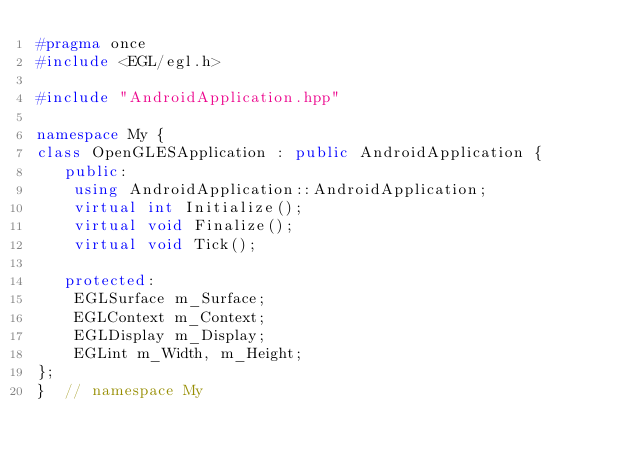Convert code to text. <code><loc_0><loc_0><loc_500><loc_500><_C++_>#pragma once
#include <EGL/egl.h>

#include "AndroidApplication.hpp"

namespace My {
class OpenGLESApplication : public AndroidApplication {
   public:
    using AndroidApplication::AndroidApplication;
    virtual int Initialize();
    virtual void Finalize();
    virtual void Tick();

   protected:
    EGLSurface m_Surface;
    EGLContext m_Context;
    EGLDisplay m_Display;
    EGLint m_Width, m_Height;
};
}  // namespace My
</code> 